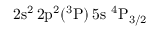<formula> <loc_0><loc_0><loc_500><loc_500>2 s ^ { 2 } \, 2 p ^ { 2 } ( ^ { 3 } P ) \, 5 s ^ { 4 } P _ { 3 / 2 }</formula> 